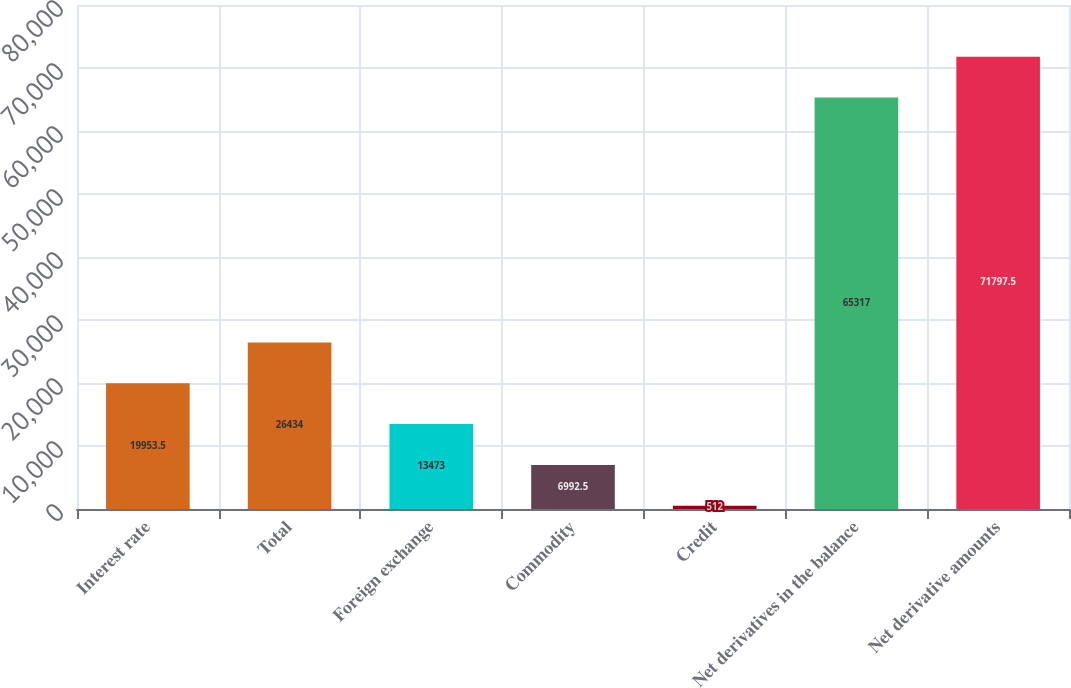Convert chart. <chart><loc_0><loc_0><loc_500><loc_500><bar_chart><fcel>Interest rate<fcel>Total<fcel>Foreign exchange<fcel>Commodity<fcel>Credit<fcel>Net derivatives in the balance<fcel>Net derivative amounts<nl><fcel>19953.5<fcel>26434<fcel>13473<fcel>6992.5<fcel>512<fcel>65317<fcel>71797.5<nl></chart> 